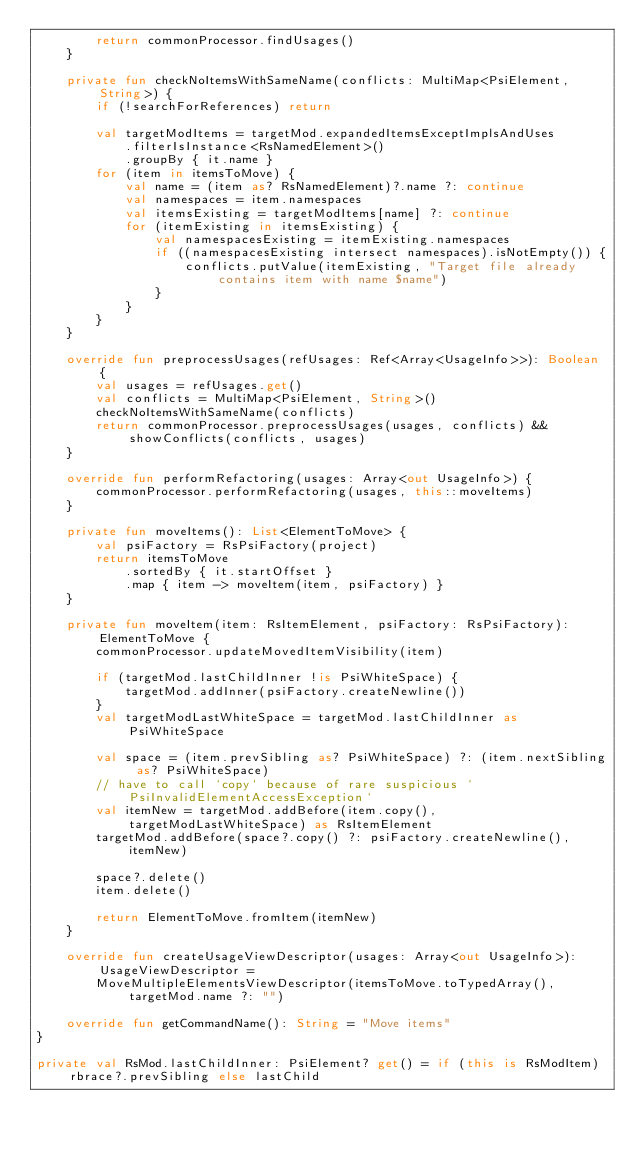Convert code to text. <code><loc_0><loc_0><loc_500><loc_500><_Kotlin_>        return commonProcessor.findUsages()
    }

    private fun checkNoItemsWithSameName(conflicts: MultiMap<PsiElement, String>) {
        if (!searchForReferences) return

        val targetModItems = targetMod.expandedItemsExceptImplsAndUses
            .filterIsInstance<RsNamedElement>()
            .groupBy { it.name }
        for (item in itemsToMove) {
            val name = (item as? RsNamedElement)?.name ?: continue
            val namespaces = item.namespaces
            val itemsExisting = targetModItems[name] ?: continue
            for (itemExisting in itemsExisting) {
                val namespacesExisting = itemExisting.namespaces
                if ((namespacesExisting intersect namespaces).isNotEmpty()) {
                    conflicts.putValue(itemExisting, "Target file already contains item with name $name")
                }
            }
        }
    }

    override fun preprocessUsages(refUsages: Ref<Array<UsageInfo>>): Boolean {
        val usages = refUsages.get()
        val conflicts = MultiMap<PsiElement, String>()
        checkNoItemsWithSameName(conflicts)
        return commonProcessor.preprocessUsages(usages, conflicts) && showConflicts(conflicts, usages)
    }

    override fun performRefactoring(usages: Array<out UsageInfo>) {
        commonProcessor.performRefactoring(usages, this::moveItems)
    }

    private fun moveItems(): List<ElementToMove> {
        val psiFactory = RsPsiFactory(project)
        return itemsToMove
            .sortedBy { it.startOffset }
            .map { item -> moveItem(item, psiFactory) }
    }

    private fun moveItem(item: RsItemElement, psiFactory: RsPsiFactory): ElementToMove {
        commonProcessor.updateMovedItemVisibility(item)

        if (targetMod.lastChildInner !is PsiWhiteSpace) {
            targetMod.addInner(psiFactory.createNewline())
        }
        val targetModLastWhiteSpace = targetMod.lastChildInner as PsiWhiteSpace

        val space = (item.prevSibling as? PsiWhiteSpace) ?: (item.nextSibling as? PsiWhiteSpace)
        // have to call `copy` because of rare suspicious `PsiInvalidElementAccessException`
        val itemNew = targetMod.addBefore(item.copy(), targetModLastWhiteSpace) as RsItemElement
        targetMod.addBefore(space?.copy() ?: psiFactory.createNewline(), itemNew)

        space?.delete()
        item.delete()

        return ElementToMove.fromItem(itemNew)
    }

    override fun createUsageViewDescriptor(usages: Array<out UsageInfo>): UsageViewDescriptor =
        MoveMultipleElementsViewDescriptor(itemsToMove.toTypedArray(), targetMod.name ?: "")

    override fun getCommandName(): String = "Move items"
}

private val RsMod.lastChildInner: PsiElement? get() = if (this is RsModItem) rbrace?.prevSibling else lastChild
</code> 